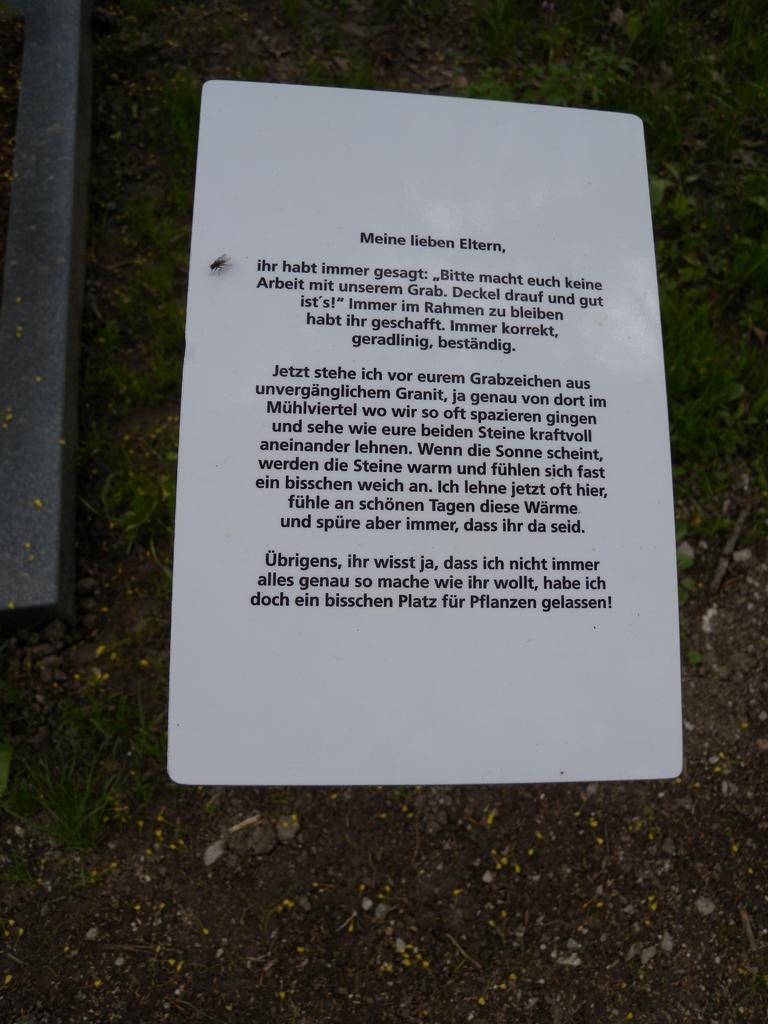What is located in the center of the image? There is a paper and a housefly in the center of the image. What is on the left side of the image? There is a metal rod on the left side of the image. What can be seen in the background of the image? Plants and the ground are visible in the background of the image. Can you tell me how many breaths the housefly takes in the image? There is no way to determine the number of breaths the housefly takes in the image, as it is a still image and not a video. What type of vein is visible in the image? There are no veins visible in the image; it features a paper, a housefly, a metal rod, plants, and the ground. 